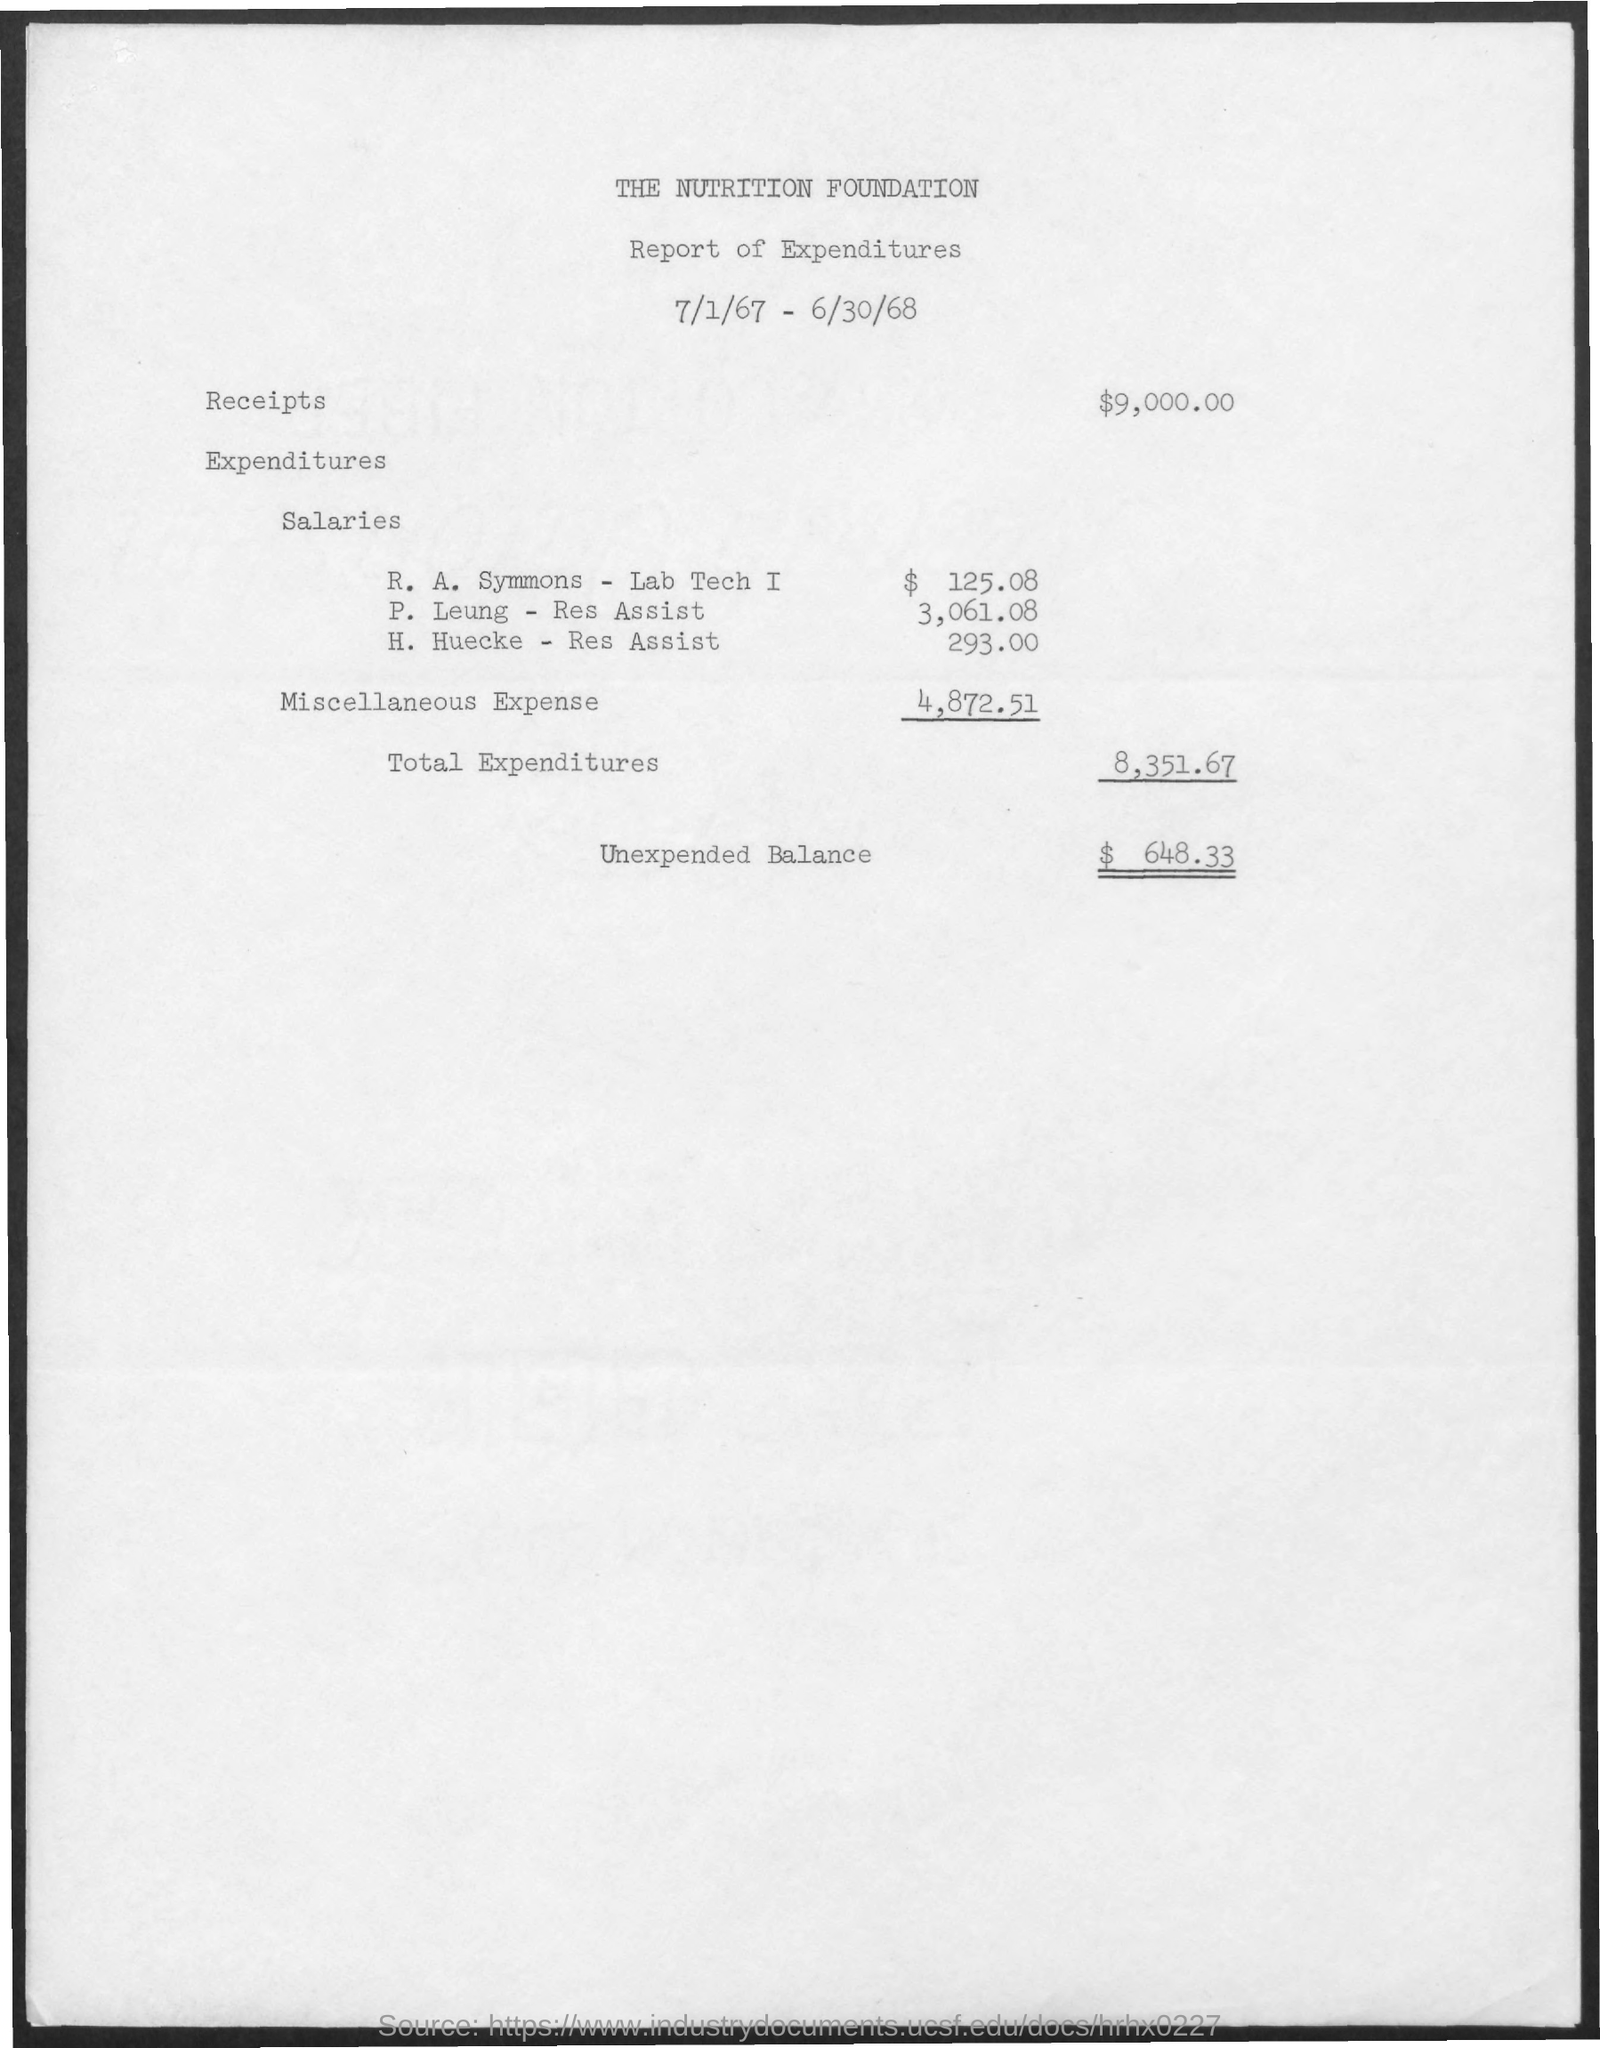What is the Salary Expenditure of R. A. Symmons - Lab Tech I?
Your response must be concise. 125.08. What is the Unexpected balance as per the document?
Your answer should be compact. $  648.33. 